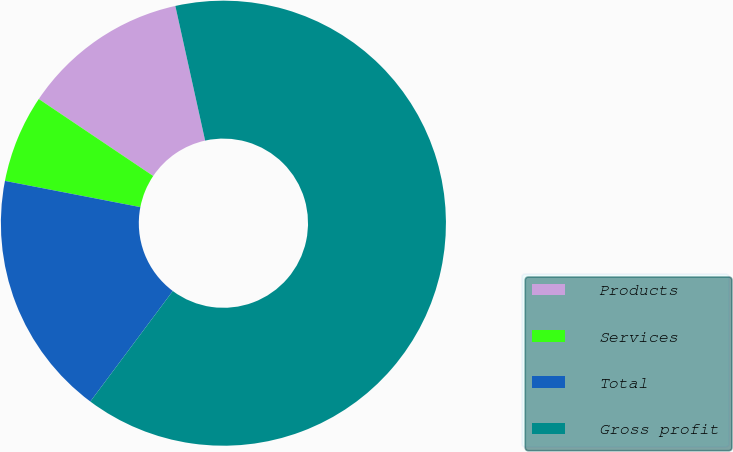<chart> <loc_0><loc_0><loc_500><loc_500><pie_chart><fcel>Products<fcel>Services<fcel>Total<fcel>Gross profit<nl><fcel>12.11%<fcel>6.38%<fcel>17.84%<fcel>63.67%<nl></chart> 